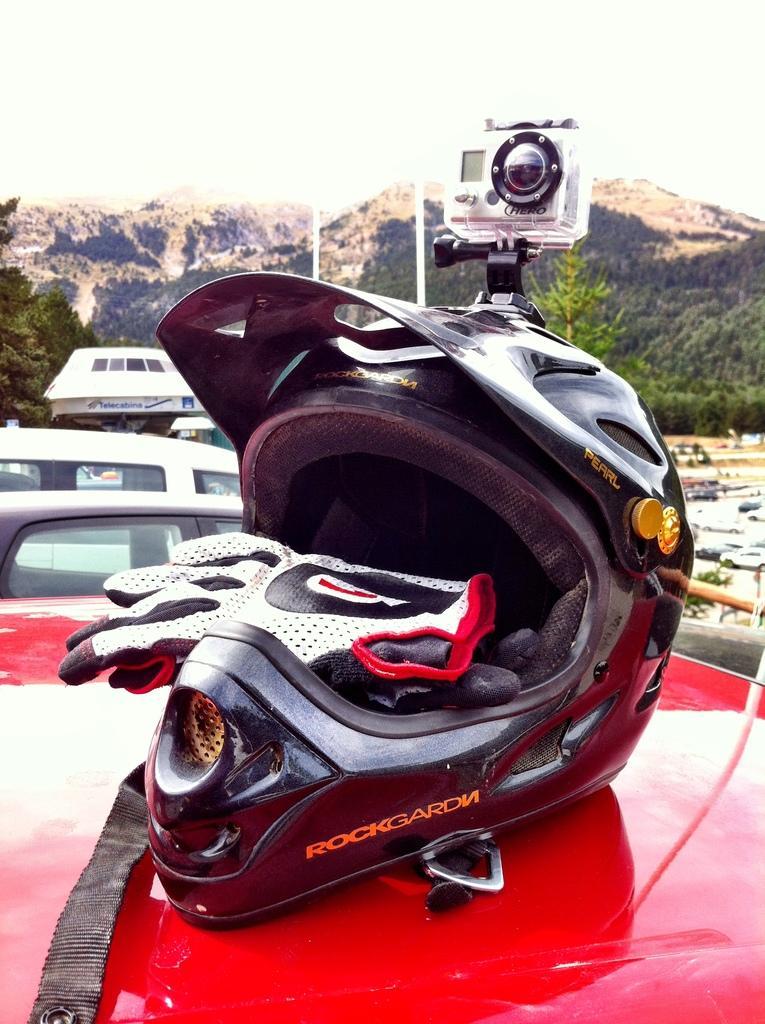How would you summarize this image in a sentence or two? In this image I can see a helmet and a pair of gloves. There is a camera on top of the helmet. In the background I can see mountains. 